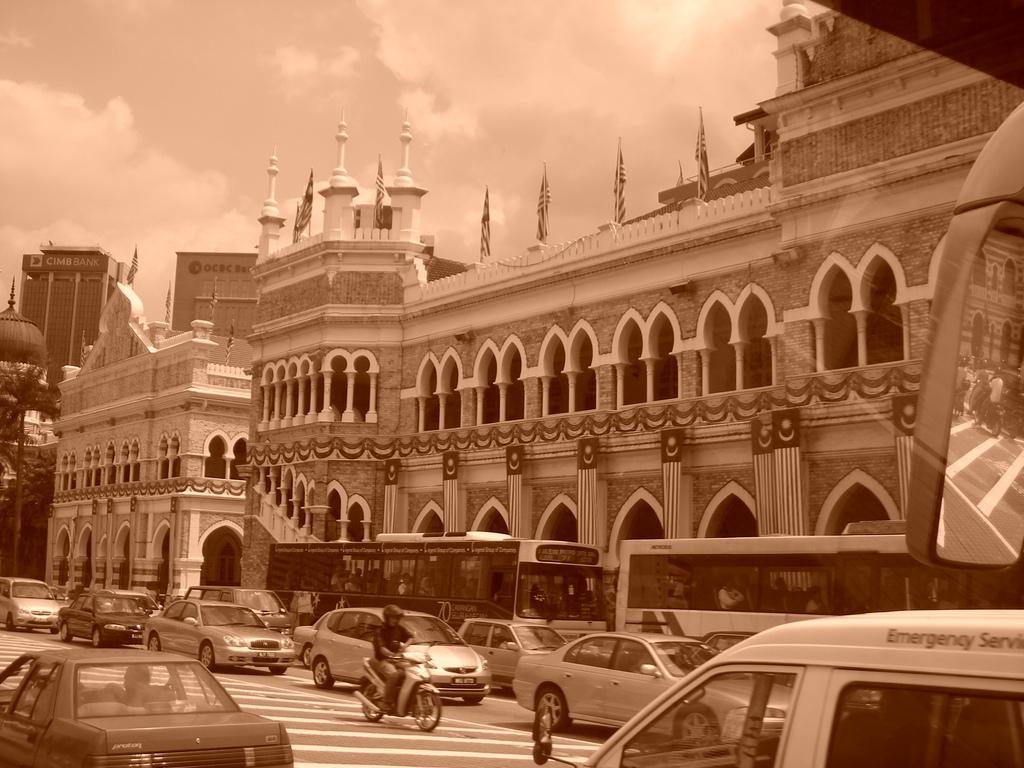Can you describe this image briefly? In this image we can see some buildings, flags, pillars, trees, and some vehicles on the road, also we can see the sky. 